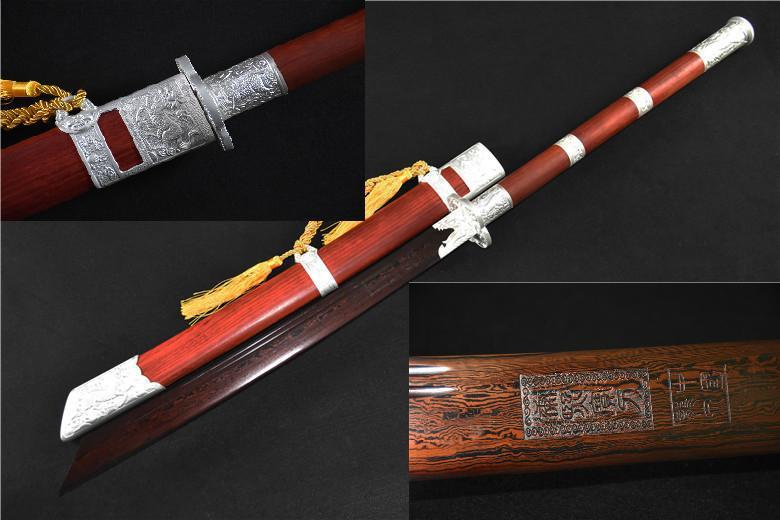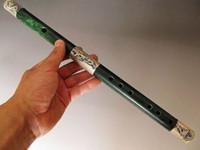The first image is the image on the left, the second image is the image on the right. Evaluate the accuracy of this statement regarding the images: "The picture on the left shows exactly two flutes side by side.". Is it true? Answer yes or no. No. The first image is the image on the left, the second image is the image on the right. Given the left and right images, does the statement "There is a white flute." hold true? Answer yes or no. No. 